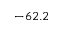<formula> <loc_0><loc_0><loc_500><loc_500>- 6 2 . 2</formula> 